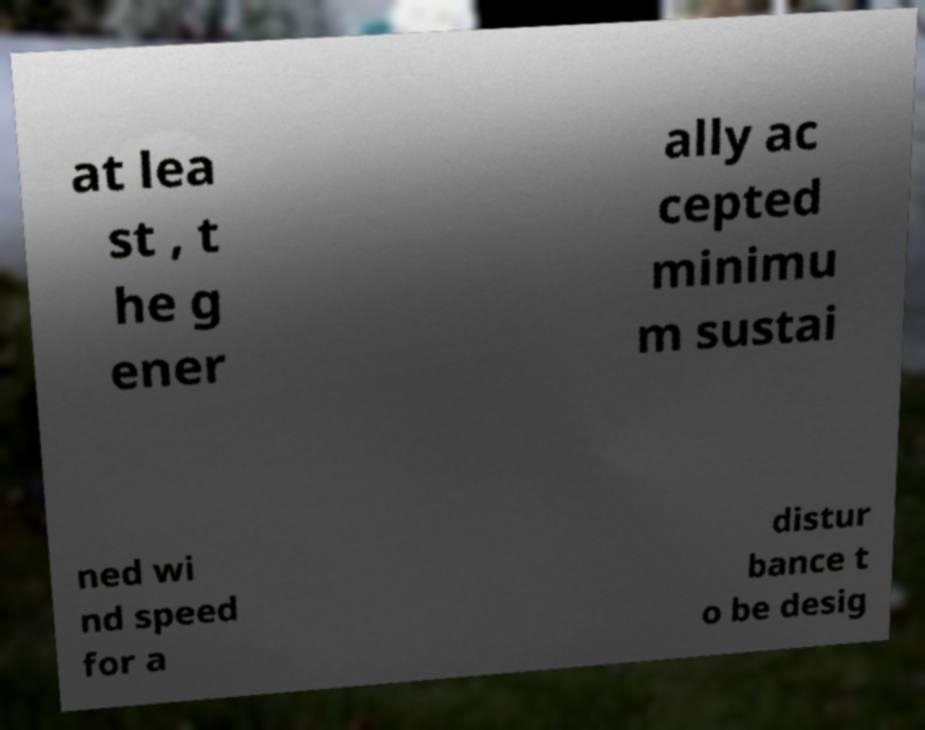What messages or text are displayed in this image? I need them in a readable, typed format. at lea st , t he g ener ally ac cepted minimu m sustai ned wi nd speed for a distur bance t o be desig 